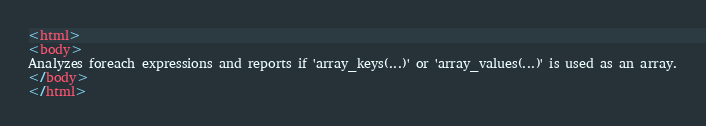<code> <loc_0><loc_0><loc_500><loc_500><_HTML_><html>
<body>
Analyzes foreach expressions and reports if 'array_keys(...)' or 'array_values(...)' is used as an array.
</body>
</html></code> 